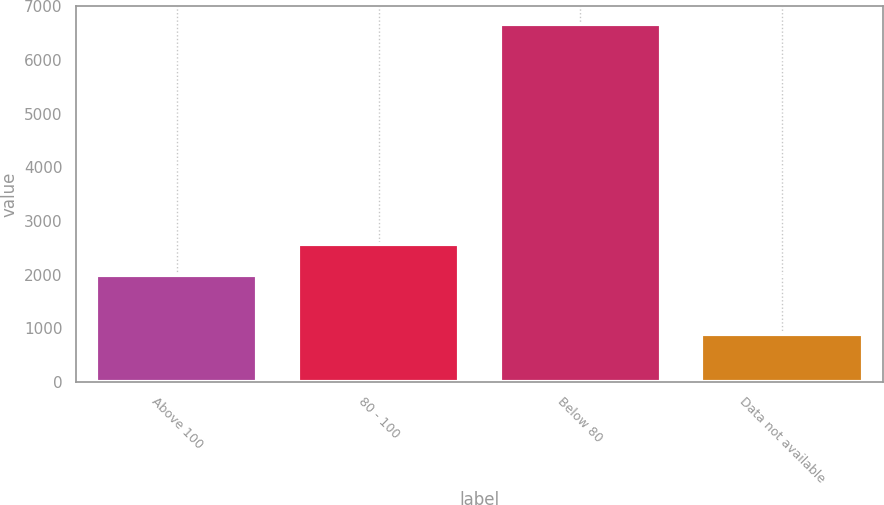<chart> <loc_0><loc_0><loc_500><loc_500><bar_chart><fcel>Above 100<fcel>80 - 100<fcel>Below 80<fcel>Data not available<nl><fcel>1988<fcel>2565.6<fcel>6677<fcel>901<nl></chart> 